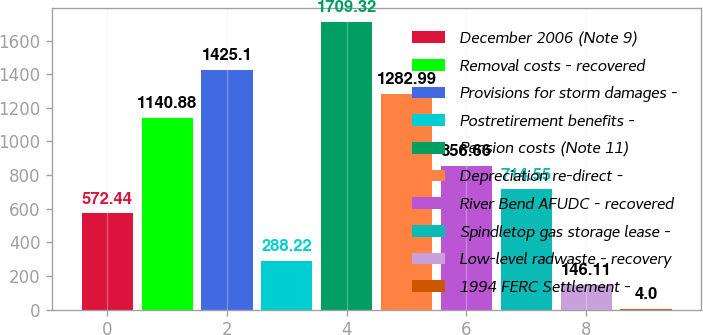Convert chart. <chart><loc_0><loc_0><loc_500><loc_500><bar_chart><fcel>December 2006 (Note 9)<fcel>Removal costs - recovered<fcel>Provisions for storm damages -<fcel>Postretirement benefits -<fcel>Pension costs (Note 11)<fcel>Depreciation re-direct -<fcel>River Bend AFUDC - recovered<fcel>Spindletop gas storage lease -<fcel>Low-level radwaste - recovery<fcel>1994 FERC Settlement -<nl><fcel>572.44<fcel>1140.88<fcel>1425.1<fcel>288.22<fcel>1709.32<fcel>1282.99<fcel>856.66<fcel>714.55<fcel>146.11<fcel>4<nl></chart> 